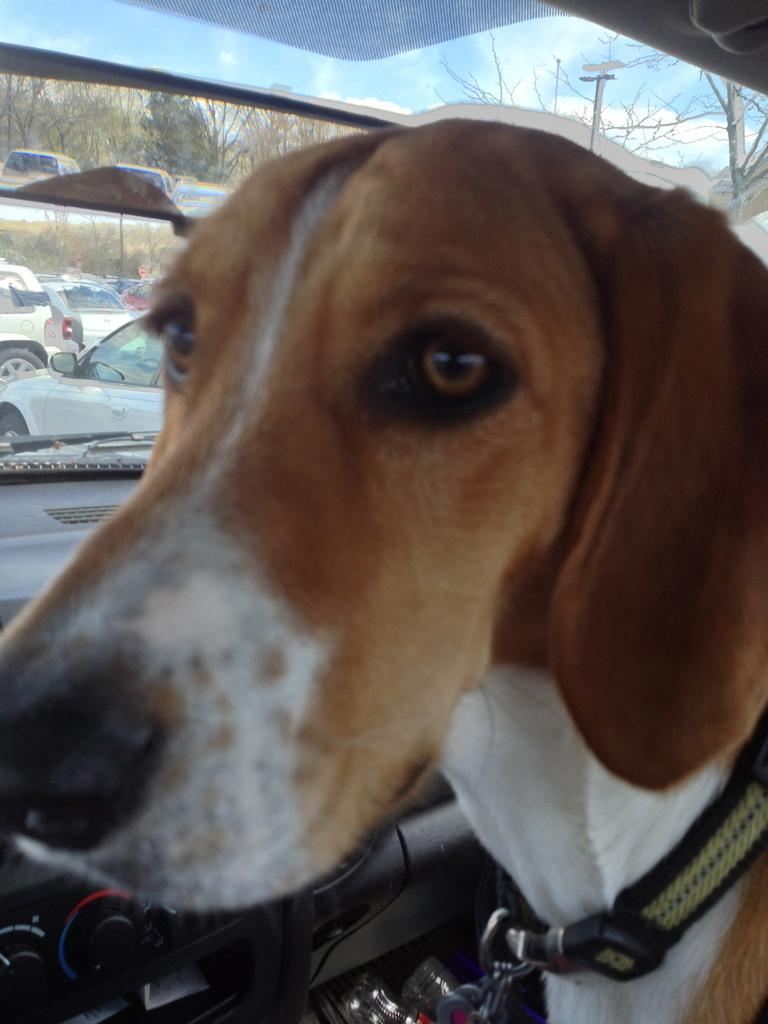What is inside the car in the image? There is a dog inside the car in the image. What can be seen through the car's window? There is a clear view of the outside through the car's window, including other cars and trees. How would you describe the sky in the image? The sky is clear and blue with clouds in the image. What type of worm can be seen crawling on the dog's fur in the image? There is no worm present in the image; the dog is inside the car with no visible worms. 